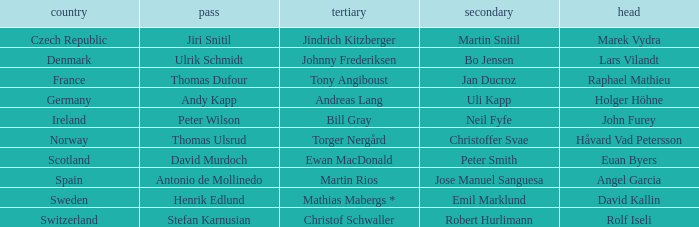Which Lead has a Nation of switzerland? Rolf Iseli. 